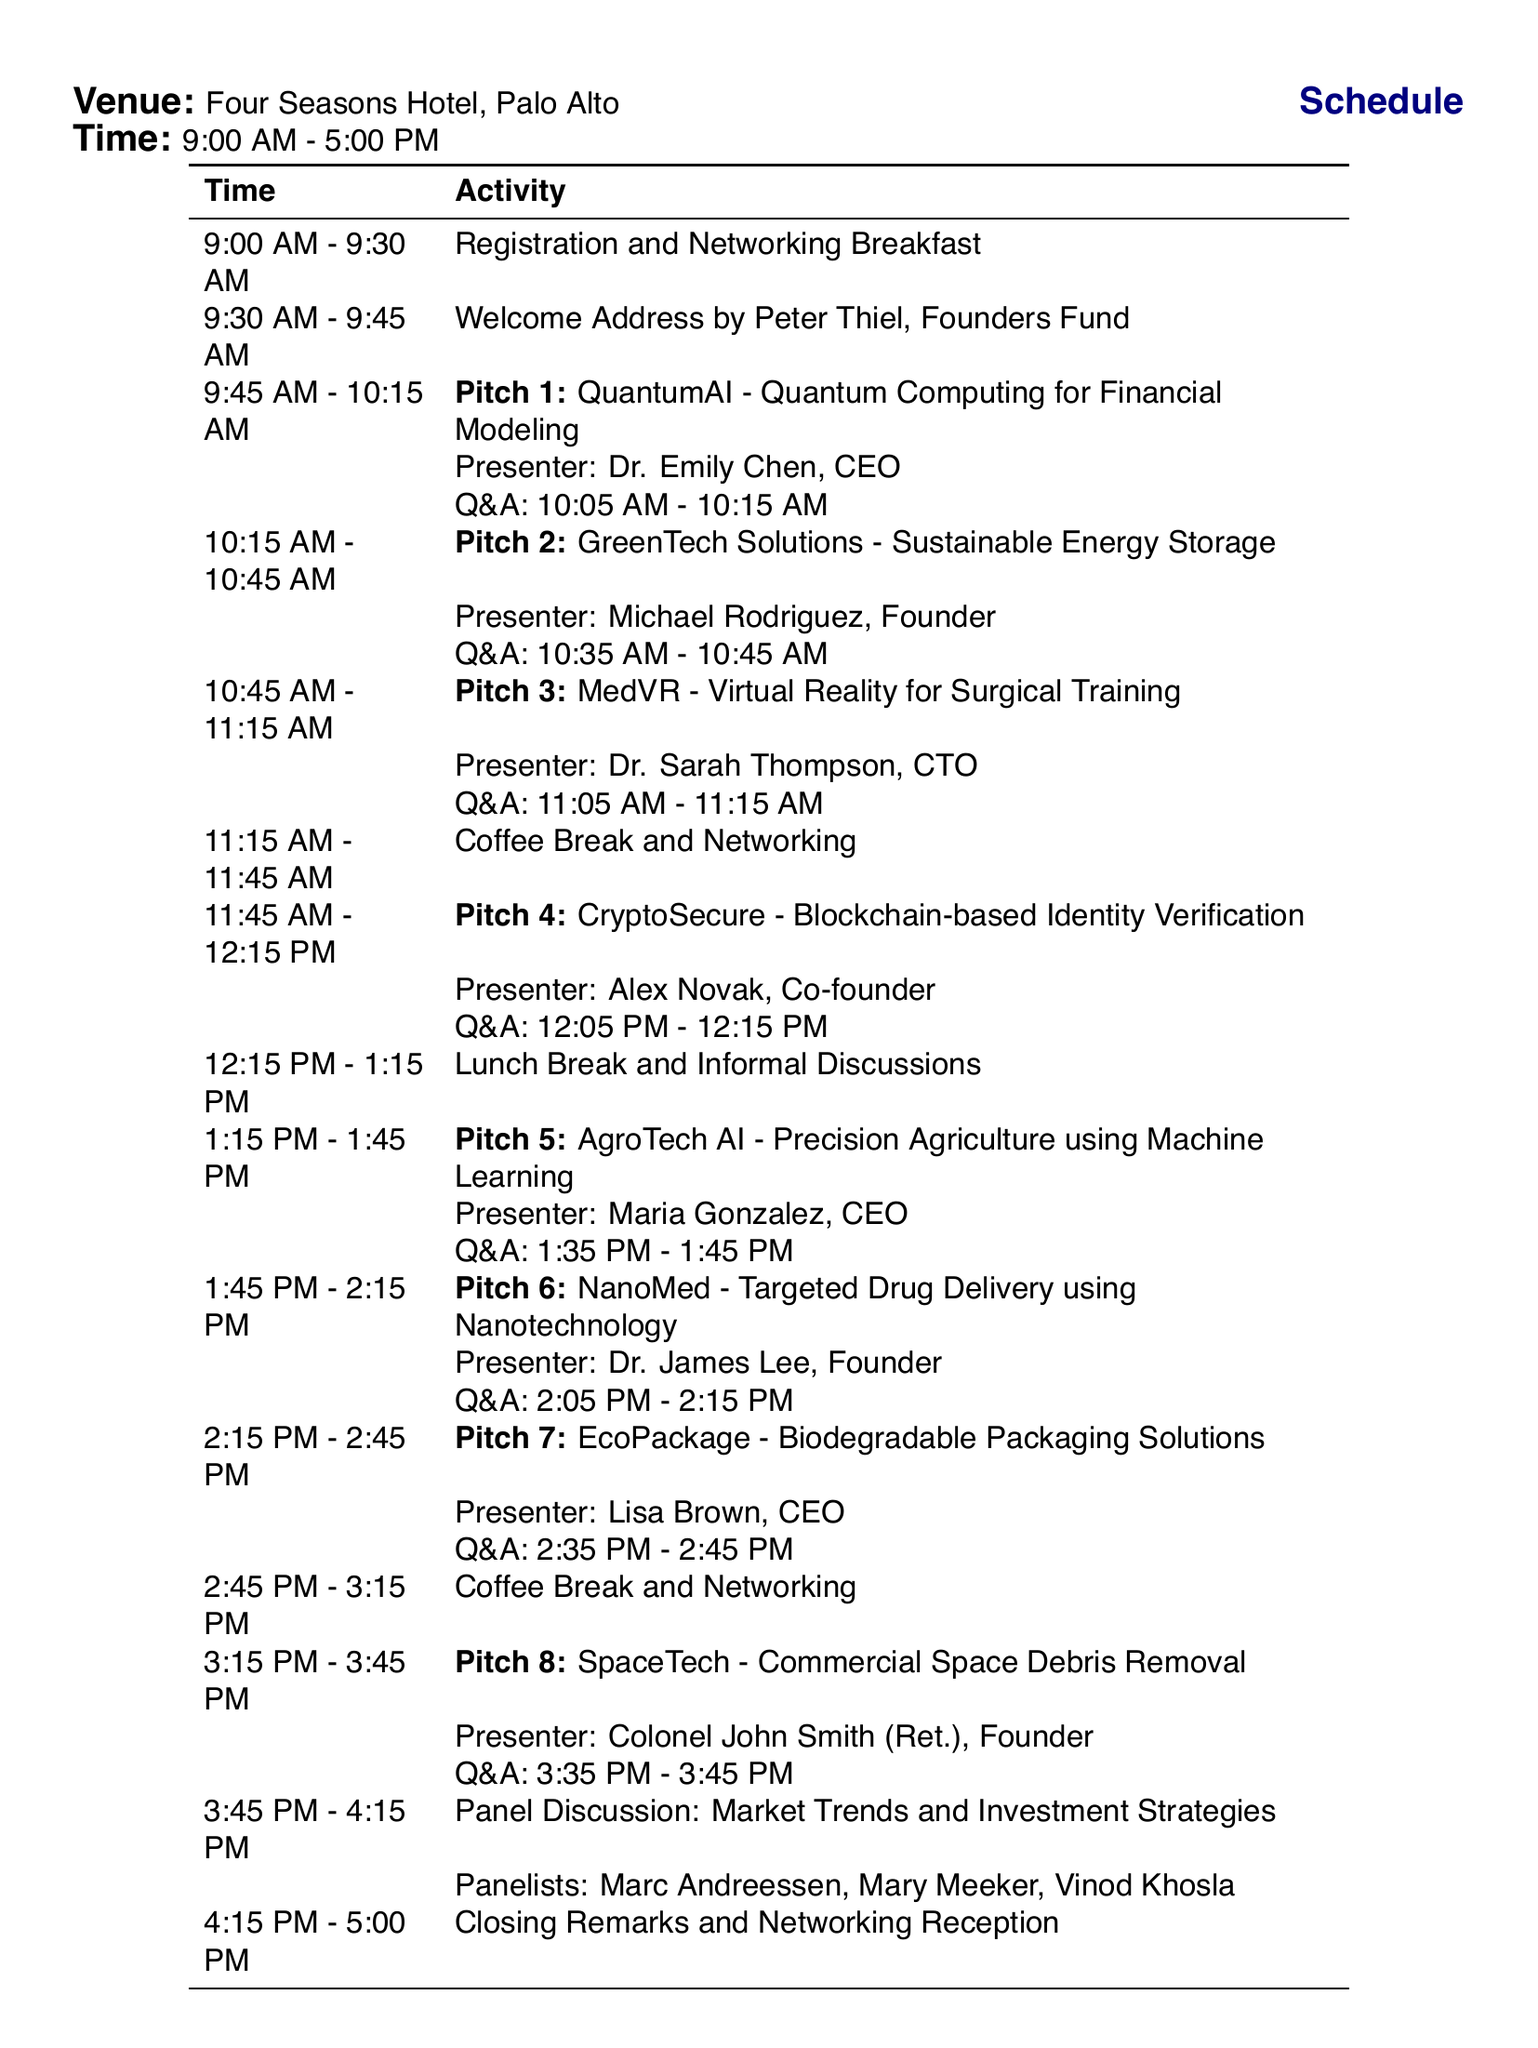What is the name of the event? The event is titled in the document.
Answer: Silicon Valley Angel Investors Pitch Day What is the date of the event? The date is explicitly mentioned in the document.
Answer: June 15, 2023 Who is the presenter for Pitch 4? The document includes the presenter's name for Pitch 4.
Answer: Alex Novak, Co-founder What time does Pitch 5 start? The start time for Pitch 5 is listed in the schedule.
Answer: 1:15 PM How long is the Q&A session for Pitch 6? The document specifies the Q&A duration for each pitch.
Answer: 10 minutes What is the location of the event? The venue is provided in the document.
Answer: Four Seasons Hotel, Palo Alto Who is moderating the panel discussion? The panelists are listed in the document, indicating the specific individuals.
Answer: Marc Andreessen, Mary Meeker, Vinod Khosla What is the focus of the investor considerations? The document lists key considerations for investors.
Answer: Market size and growth potential, Competitive landscape and barriers to entry, Revenue model and scalability, Team experience and track record, Intellectual property and defensibility, Financial projections and funding requirements, Exit strategy and potential acquirers What type of activity is scheduled right after the Welcome Address? The type of activity immediately following is stated in the schedule.
Answer: Pitch 1: QuantumAI - Quantum Computing for Financial Modeling 